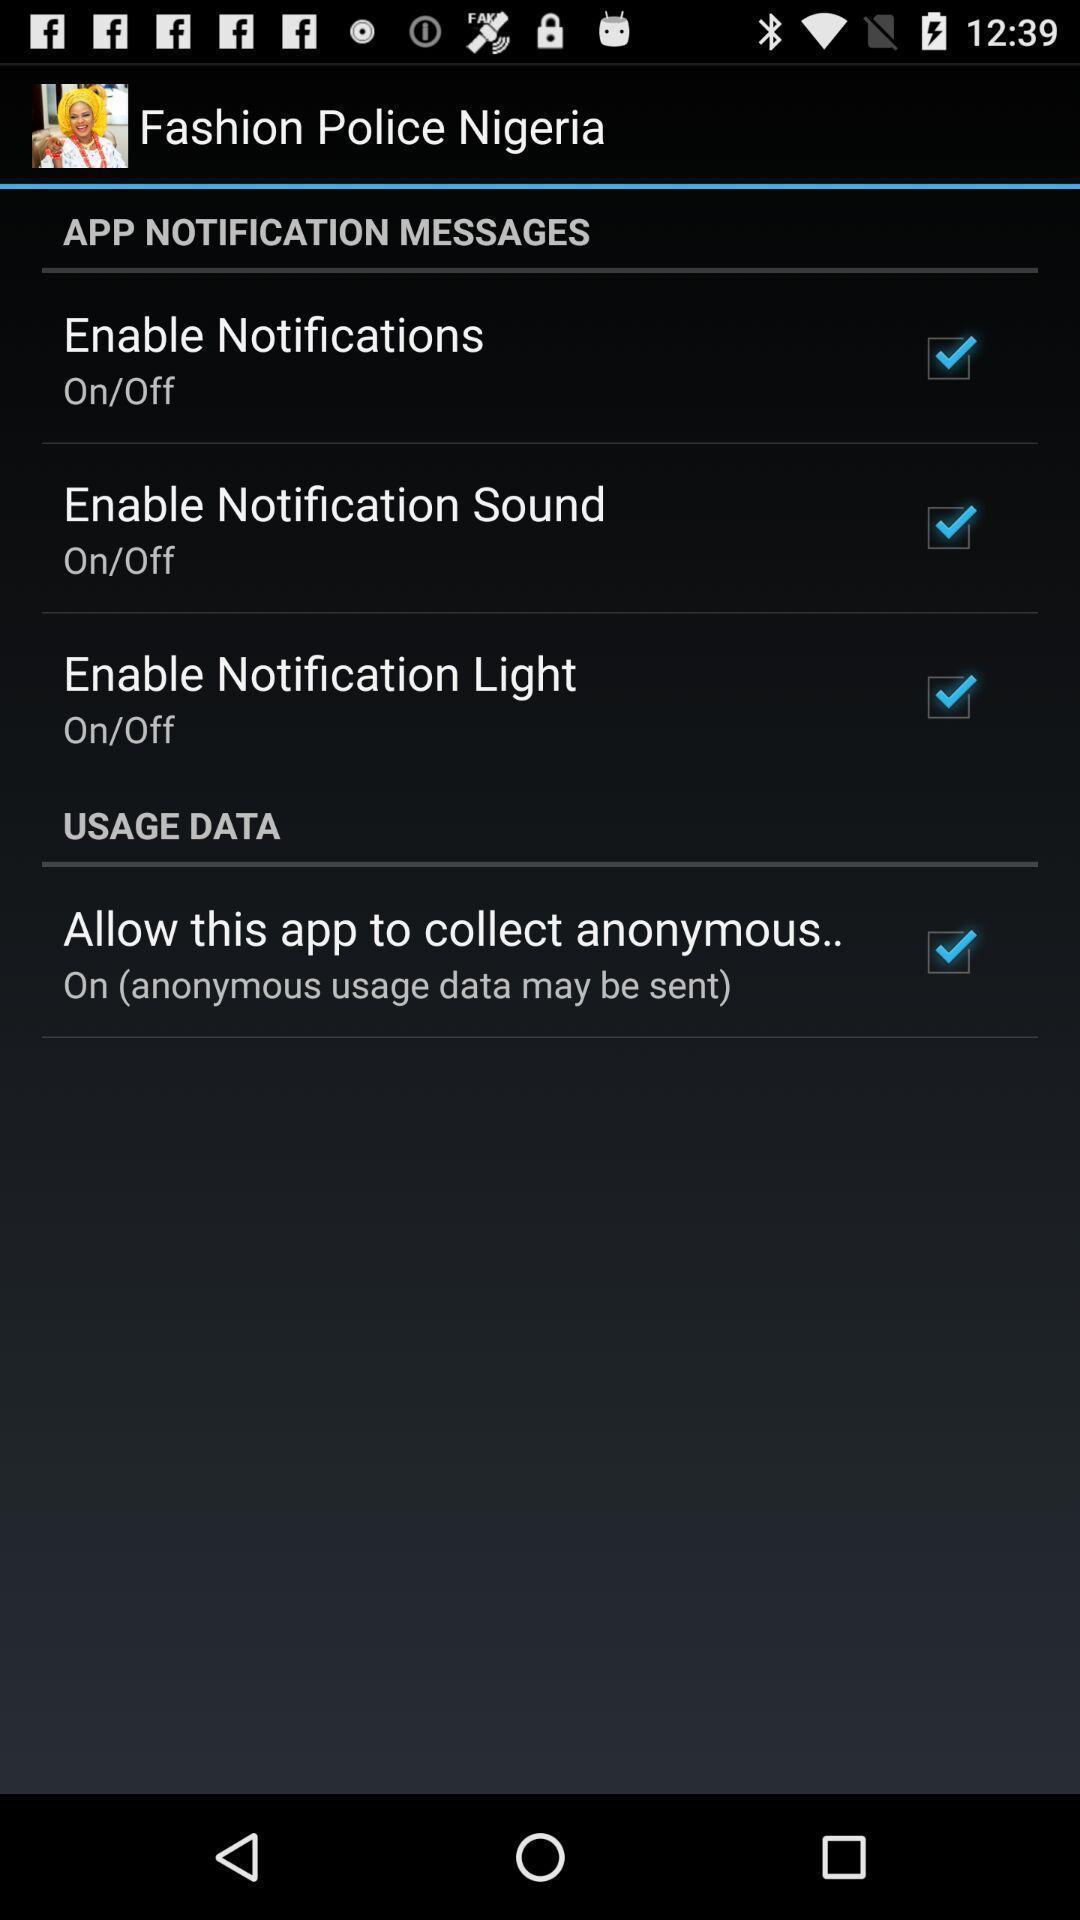Please provide a description for this image. Page showing options for notification. 